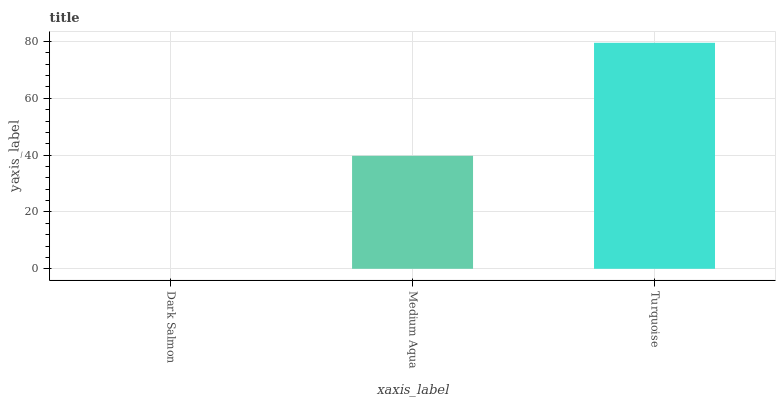Is Dark Salmon the minimum?
Answer yes or no. Yes. Is Turquoise the maximum?
Answer yes or no. Yes. Is Medium Aqua the minimum?
Answer yes or no. No. Is Medium Aqua the maximum?
Answer yes or no. No. Is Medium Aqua greater than Dark Salmon?
Answer yes or no. Yes. Is Dark Salmon less than Medium Aqua?
Answer yes or no. Yes. Is Dark Salmon greater than Medium Aqua?
Answer yes or no. No. Is Medium Aqua less than Dark Salmon?
Answer yes or no. No. Is Medium Aqua the high median?
Answer yes or no. Yes. Is Medium Aqua the low median?
Answer yes or no. Yes. Is Turquoise the high median?
Answer yes or no. No. Is Dark Salmon the low median?
Answer yes or no. No. 